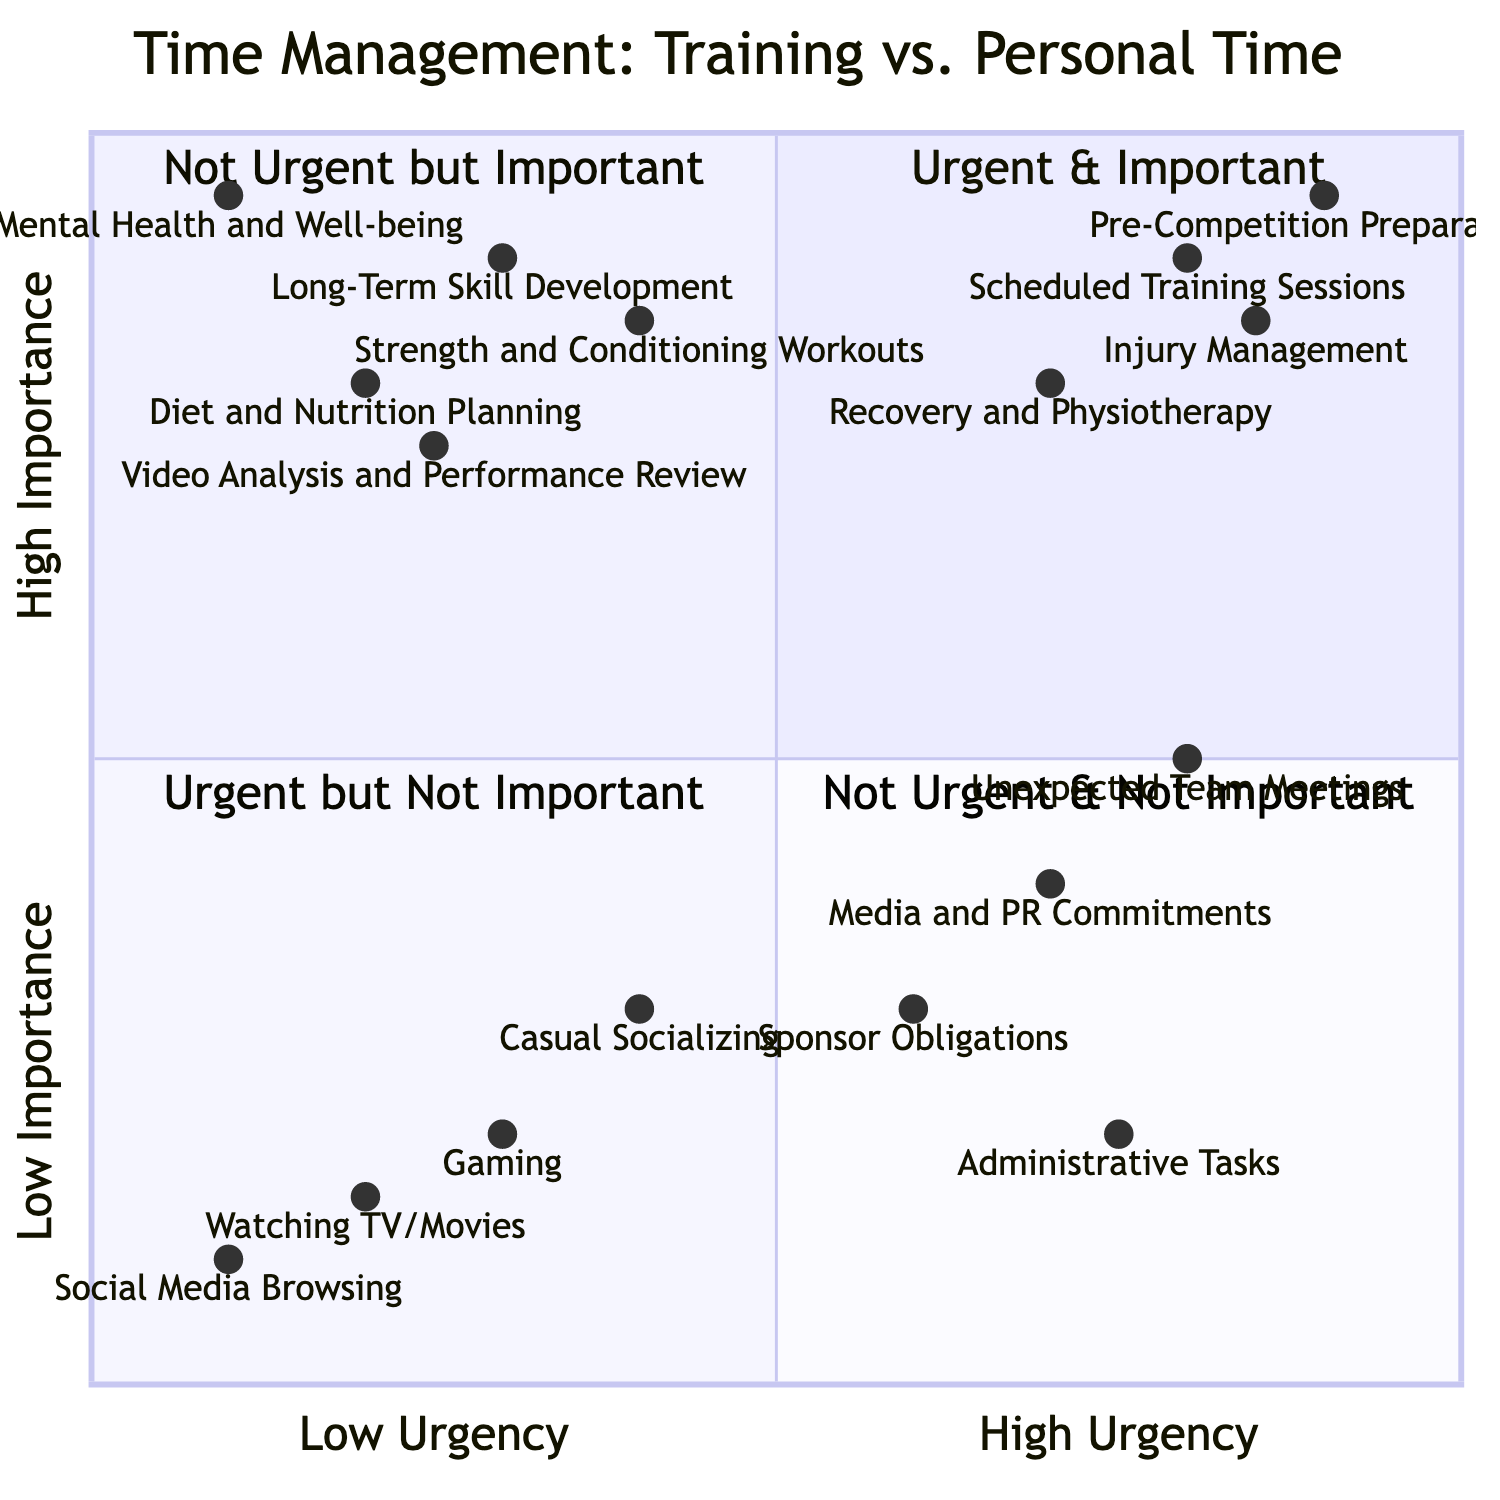What are the elements in the "Urgent & Important" quadrant? Viewing the "Urgent & Important" quadrant, the items listed there are scheduled training sessions, recovery and physiotherapy, pre-competition preparations, and injury management.
Answer: Scheduled Training Sessions, Recovery and Physiotherapy, Pre-Competition Preparations, Injury Management Which element is located at the highest importance in the chart? Upon examining the coordinates, "Pre-Competition Preparations" has an importance value of 0.95, which is the highest among all elements in the chart.
Answer: Pre-Competition Preparations How many elements fall under "Not Urgent but Important"? By counting the elements in the "Not Urgent but Important" quadrant, there are five listed: long-term skill development, diet and nutrition planning, strength and conditioning workouts, mental health and well-being, and video analysis and performance review.
Answer: Five Which activity has the lowest urgency? Checking the coordinates, "Social Media Browsing" has an urgency value of 0.1, indicating it is the activity with the lowest urgency in the chart.
Answer: Social Media Browsing How does the urgency of "Media and PR Commitments" compare to "Injury Management"? Comparing their urgency values, "Media and PR Commitments" has an urgency value of 0.7 while "Injury Management" has a value of 0.85, indicating that "Injury Management" is more urgent.
Answer: Injury Management is more urgent What quadrant contains "Gaming"? The "Gaming" element is found in the "Not Urgent & Not Important" quadrant, as indicated by its coordinates and category classification.
Answer: Not Urgent & Not Important What is the relationship between "Diet and Nutrition Planning" and "Strength and Conditioning Workouts"? Both "Diet and Nutrition Planning" and "Strength and Conditioning Workouts" are situated in the "Not Urgent but Important" quadrant, suggesting that they are important for long-term performance but not currently urgent.
Answer: Both in Not Urgent but Important quadrant What is the total number of elements in the "Urgent but Not Important" quadrant? There are four elements listed in the "Urgent but Not Important" quadrant, which are media and PR commitments, sponsor obligations, unexpected team meetings, and administrative tasks.
Answer: Four 